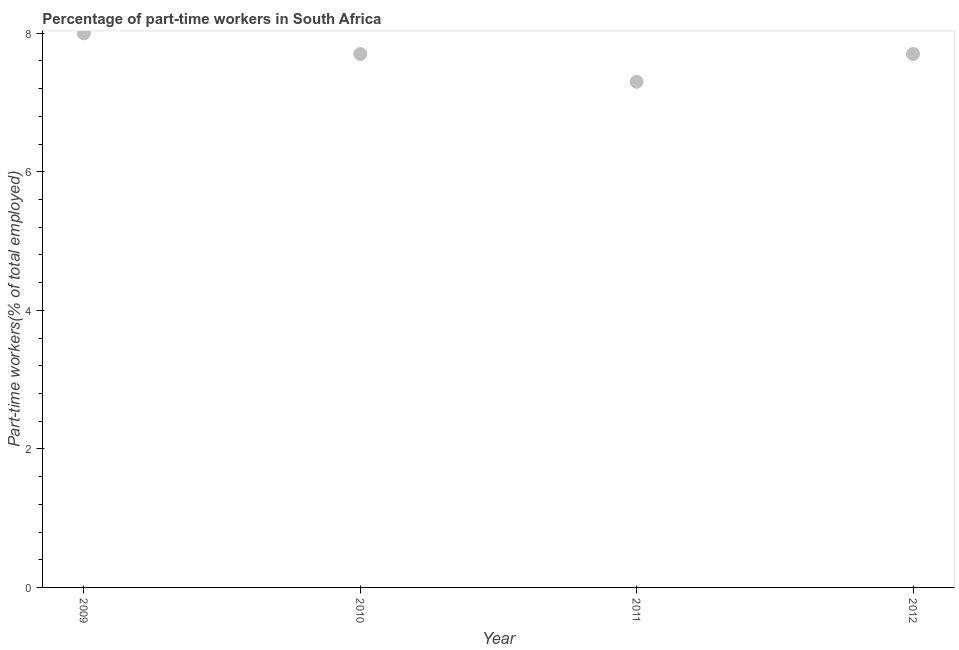What is the percentage of part-time workers in 2010?
Offer a terse response. 7.7. Across all years, what is the minimum percentage of part-time workers?
Keep it short and to the point. 7.3. In which year was the percentage of part-time workers maximum?
Ensure brevity in your answer.  2009. In which year was the percentage of part-time workers minimum?
Keep it short and to the point. 2011. What is the sum of the percentage of part-time workers?
Your answer should be very brief. 30.7. What is the difference between the percentage of part-time workers in 2009 and 2011?
Ensure brevity in your answer.  0.7. What is the average percentage of part-time workers per year?
Make the answer very short. 7.67. What is the median percentage of part-time workers?
Give a very brief answer. 7.7. In how many years, is the percentage of part-time workers greater than 4.8 %?
Provide a succinct answer. 4. What is the ratio of the percentage of part-time workers in 2010 to that in 2011?
Your response must be concise. 1.05. Is the percentage of part-time workers in 2009 less than that in 2012?
Provide a short and direct response. No. What is the difference between the highest and the second highest percentage of part-time workers?
Provide a short and direct response. 0.3. What is the difference between the highest and the lowest percentage of part-time workers?
Your answer should be compact. 0.7. How many dotlines are there?
Your answer should be compact. 1. How many years are there in the graph?
Make the answer very short. 4. What is the difference between two consecutive major ticks on the Y-axis?
Your answer should be very brief. 2. Are the values on the major ticks of Y-axis written in scientific E-notation?
Offer a terse response. No. What is the title of the graph?
Provide a succinct answer. Percentage of part-time workers in South Africa. What is the label or title of the X-axis?
Your answer should be compact. Year. What is the label or title of the Y-axis?
Offer a terse response. Part-time workers(% of total employed). What is the Part-time workers(% of total employed) in 2009?
Provide a short and direct response. 8. What is the Part-time workers(% of total employed) in 2010?
Give a very brief answer. 7.7. What is the Part-time workers(% of total employed) in 2011?
Ensure brevity in your answer.  7.3. What is the Part-time workers(% of total employed) in 2012?
Offer a very short reply. 7.7. What is the difference between the Part-time workers(% of total employed) in 2009 and 2011?
Offer a terse response. 0.7. What is the difference between the Part-time workers(% of total employed) in 2010 and 2011?
Make the answer very short. 0.4. What is the difference between the Part-time workers(% of total employed) in 2010 and 2012?
Offer a very short reply. 0. What is the ratio of the Part-time workers(% of total employed) in 2009 to that in 2010?
Your answer should be compact. 1.04. What is the ratio of the Part-time workers(% of total employed) in 2009 to that in 2011?
Your answer should be very brief. 1.1. What is the ratio of the Part-time workers(% of total employed) in 2009 to that in 2012?
Your response must be concise. 1.04. What is the ratio of the Part-time workers(% of total employed) in 2010 to that in 2011?
Your answer should be compact. 1.05. What is the ratio of the Part-time workers(% of total employed) in 2010 to that in 2012?
Keep it short and to the point. 1. What is the ratio of the Part-time workers(% of total employed) in 2011 to that in 2012?
Keep it short and to the point. 0.95. 